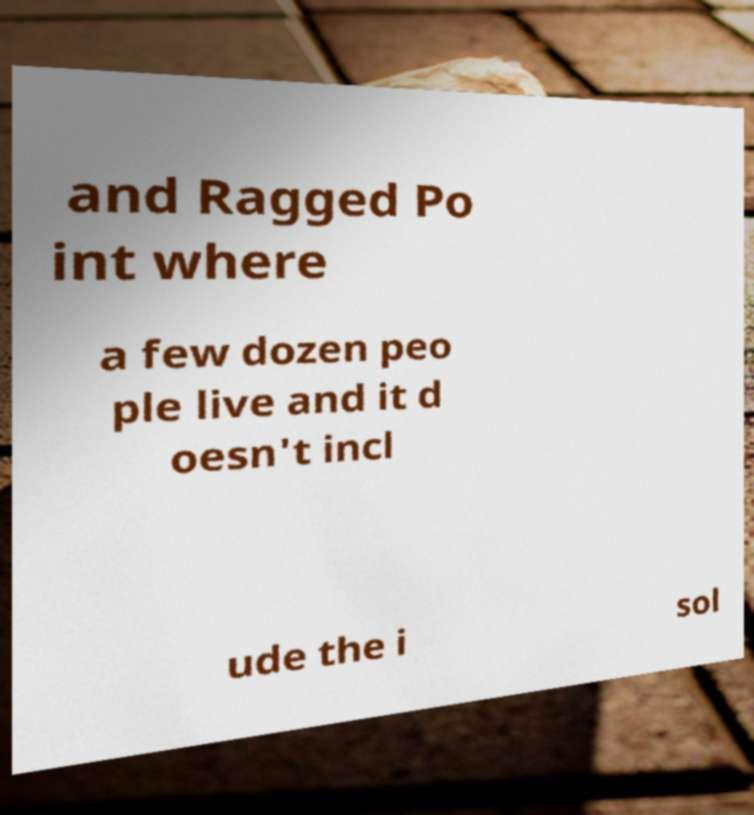Could you extract and type out the text from this image? and Ragged Po int where a few dozen peo ple live and it d oesn't incl ude the i sol 